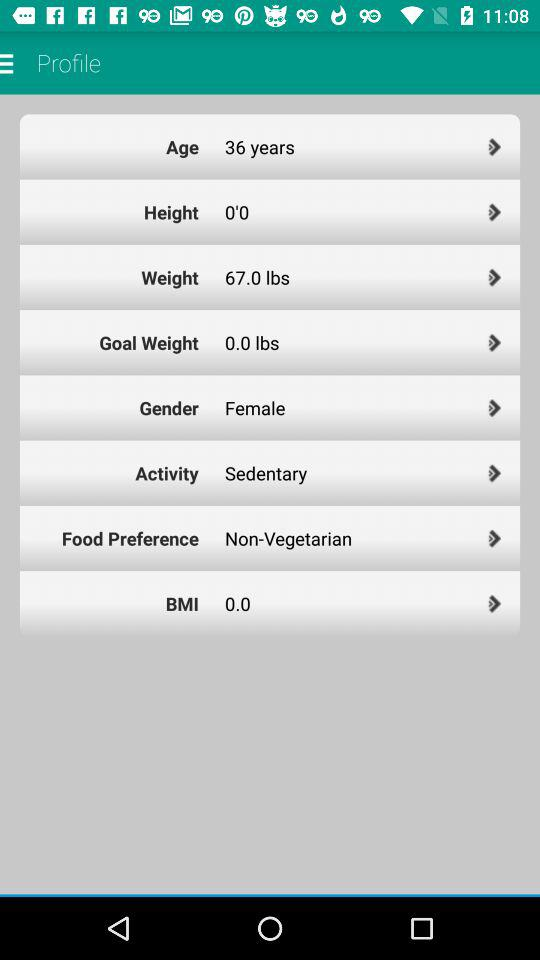What is the BMI value? The BMI value is 0.0. 